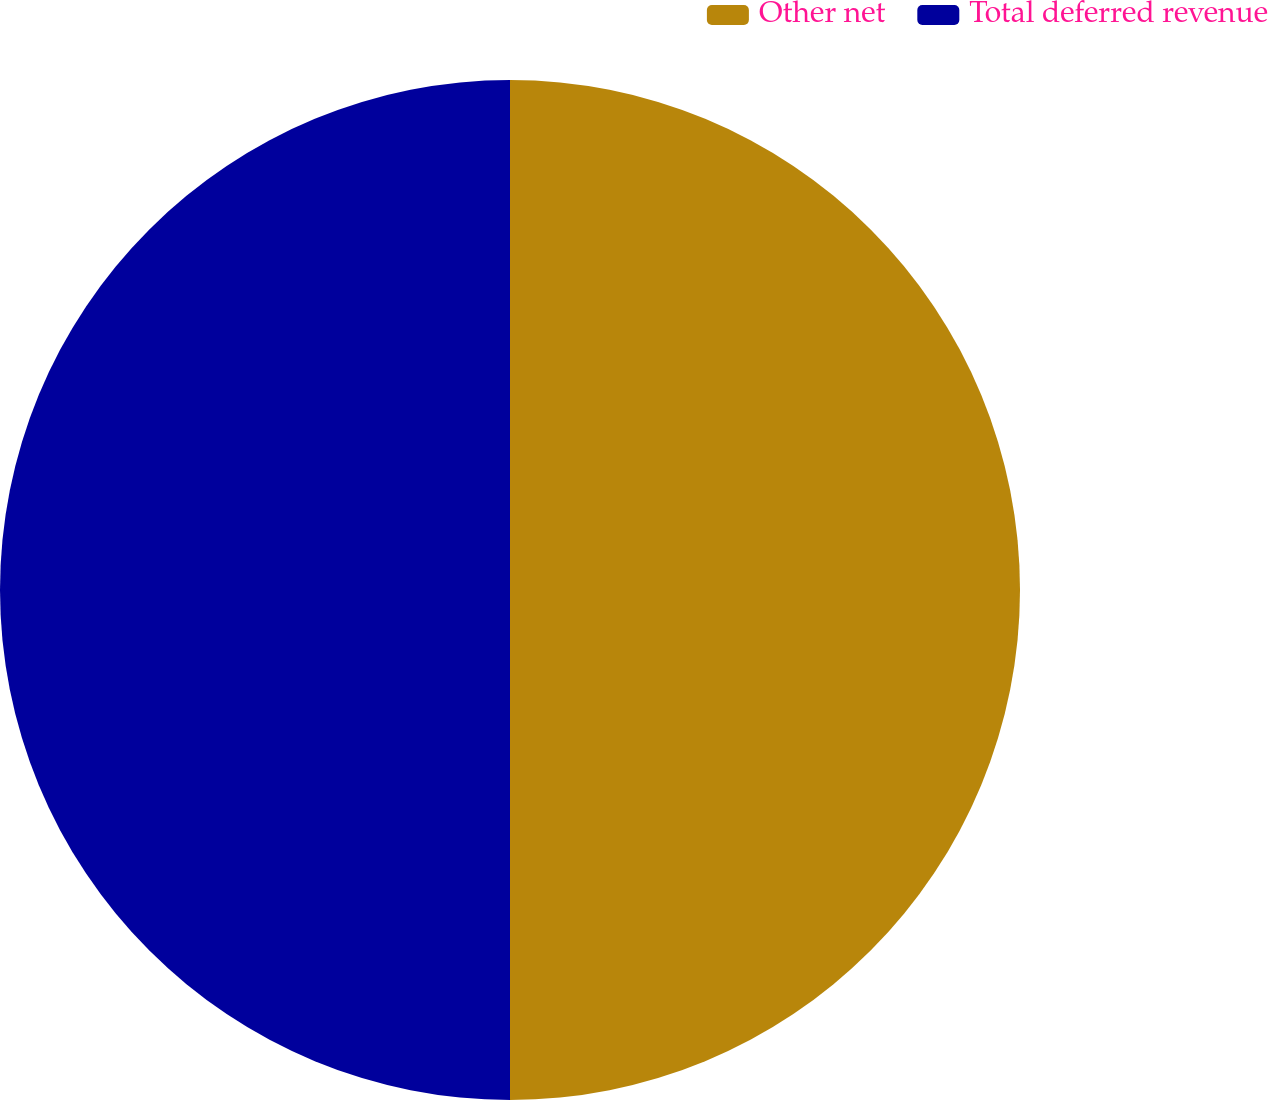Convert chart to OTSL. <chart><loc_0><loc_0><loc_500><loc_500><pie_chart><fcel>Other net<fcel>Total deferred revenue<nl><fcel>50.0%<fcel>50.0%<nl></chart> 